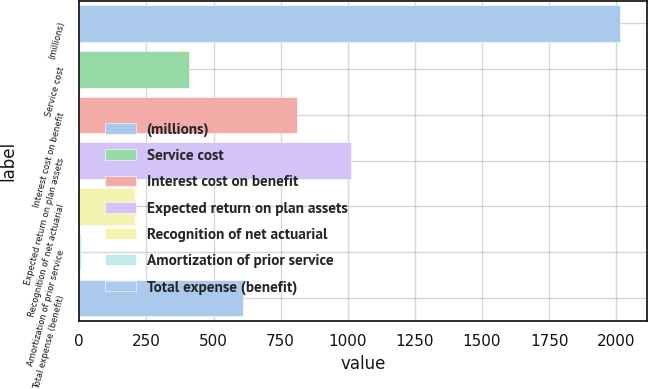<chart> <loc_0><loc_0><loc_500><loc_500><bar_chart><fcel>(millions)<fcel>Service cost<fcel>Interest cost on benefit<fcel>Expected return on plan assets<fcel>Recognition of net actuarial<fcel>Amortization of prior service<fcel>Total expense (benefit)<nl><fcel>2015<fcel>408.52<fcel>810.14<fcel>1010.95<fcel>207.71<fcel>6.9<fcel>609.33<nl></chart> 